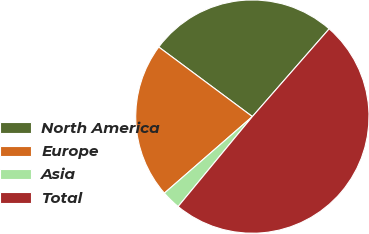<chart> <loc_0><loc_0><loc_500><loc_500><pie_chart><fcel>North America<fcel>Europe<fcel>Asia<fcel>Total<nl><fcel>26.27%<fcel>21.57%<fcel>2.62%<fcel>49.54%<nl></chart> 